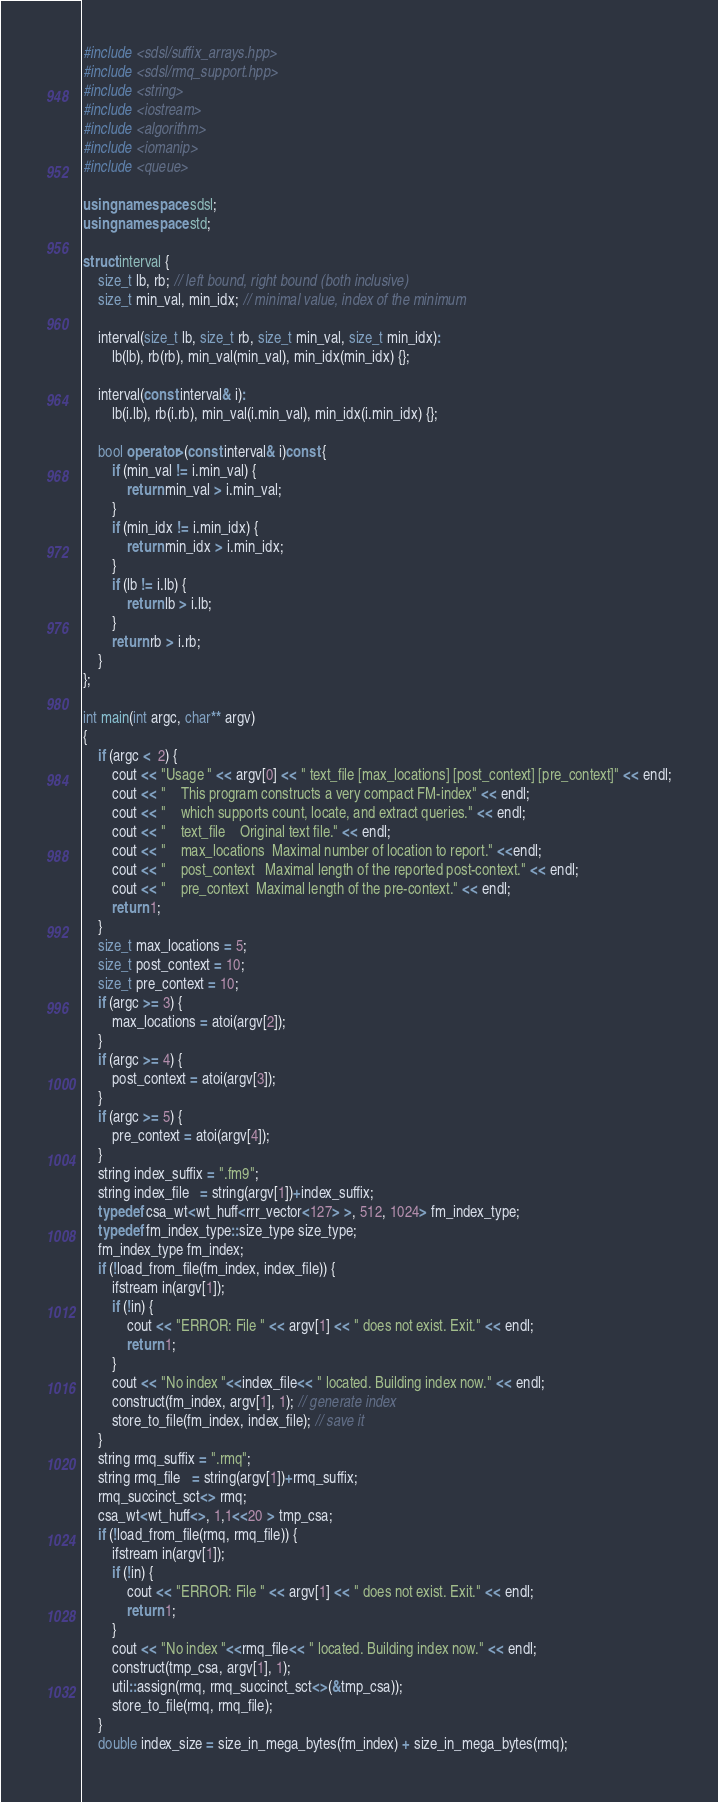Convert code to text. <code><loc_0><loc_0><loc_500><loc_500><_C++_>#include <sdsl/suffix_arrays.hpp>
#include <sdsl/rmq_support.hpp>
#include <string>
#include <iostream>
#include <algorithm>
#include <iomanip>
#include <queue>

using namespace sdsl;
using namespace std;

struct interval {
    size_t lb, rb; // left bound, right bound (both inclusive)
    size_t min_val, min_idx; // minimal value, index of the minimum

    interval(size_t lb, size_t rb, size_t min_val, size_t min_idx):
        lb(lb), rb(rb), min_val(min_val), min_idx(min_idx) {};

    interval(const interval& i):
        lb(i.lb), rb(i.rb), min_val(i.min_val), min_idx(i.min_idx) {};

    bool operator>(const interval& i)const {
        if (min_val != i.min_val) {
            return min_val > i.min_val;
        }
        if (min_idx != i.min_idx) {
            return min_idx > i.min_idx;
        }
        if (lb != i.lb) {
            return lb > i.lb;
        }
        return rb > i.rb;
    }
};

int main(int argc, char** argv)
{
    if (argc <  2) {
        cout << "Usage " << argv[0] << " text_file [max_locations] [post_context] [pre_context]" << endl;
        cout << "    This program constructs a very compact FM-index" << endl;
        cout << "    which supports count, locate, and extract queries." << endl;
        cout << "    text_file    Original text file." << endl;
        cout << "    max_locations  Maximal number of location to report." <<endl;
        cout << "    post_context   Maximal length of the reported post-context." << endl;
        cout << "    pre_context  Maximal length of the pre-context." << endl;
        return 1;
    }
    size_t max_locations = 5;
    size_t post_context = 10;
    size_t pre_context = 10;
    if (argc >= 3) {
        max_locations = atoi(argv[2]);
    }
    if (argc >= 4) {
        post_context = atoi(argv[3]);
    }
    if (argc >= 5) {
        pre_context = atoi(argv[4]);
    }
    string index_suffix = ".fm9";
    string index_file   = string(argv[1])+index_suffix;
    typedef csa_wt<wt_huff<rrr_vector<127> >, 512, 1024> fm_index_type;
    typedef fm_index_type::size_type size_type;
    fm_index_type fm_index;
    if (!load_from_file(fm_index, index_file)) {
        ifstream in(argv[1]);
        if (!in) {
            cout << "ERROR: File " << argv[1] << " does not exist. Exit." << endl;
            return 1;
        }
        cout << "No index "<<index_file<< " located. Building index now." << endl;
        construct(fm_index, argv[1], 1); // generate index
        store_to_file(fm_index, index_file); // save it
    }
    string rmq_suffix = ".rmq";
    string rmq_file   = string(argv[1])+rmq_suffix;
    rmq_succinct_sct<> rmq;
    csa_wt<wt_huff<>, 1,1<<20 > tmp_csa;
    if (!load_from_file(rmq, rmq_file)) {
        ifstream in(argv[1]);
        if (!in) {
            cout << "ERROR: File " << argv[1] << " does not exist. Exit." << endl;
            return 1;
        }
        cout << "No index "<<rmq_file<< " located. Building index now." << endl;
        construct(tmp_csa, argv[1], 1);
        util::assign(rmq, rmq_succinct_sct<>(&tmp_csa));
        store_to_file(rmq, rmq_file);
    }
    double index_size = size_in_mega_bytes(fm_index) + size_in_mega_bytes(rmq);</code> 